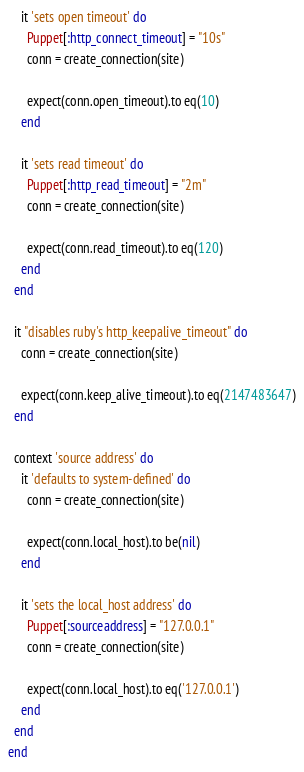<code> <loc_0><loc_0><loc_500><loc_500><_Ruby_>    it 'sets open timeout' do
      Puppet[:http_connect_timeout] = "10s"
      conn = create_connection(site)

      expect(conn.open_timeout).to eq(10)
    end

    it 'sets read timeout' do
      Puppet[:http_read_timeout] = "2m"
      conn = create_connection(site)

      expect(conn.read_timeout).to eq(120)
    end
  end

  it "disables ruby's http_keepalive_timeout" do
    conn = create_connection(site)

    expect(conn.keep_alive_timeout).to eq(2147483647)
  end

  context 'source address' do
    it 'defaults to system-defined' do
      conn = create_connection(site)

      expect(conn.local_host).to be(nil)
    end

    it 'sets the local_host address' do
      Puppet[:sourceaddress] = "127.0.0.1"
      conn = create_connection(site)

      expect(conn.local_host).to eq('127.0.0.1')
    end
  end
end
</code> 